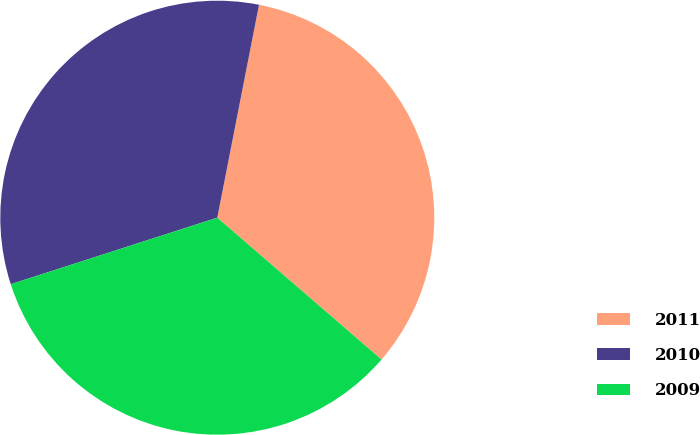Convert chart. <chart><loc_0><loc_0><loc_500><loc_500><pie_chart><fcel>2011<fcel>2010<fcel>2009<nl><fcel>33.26%<fcel>33.04%<fcel>33.7%<nl></chart> 